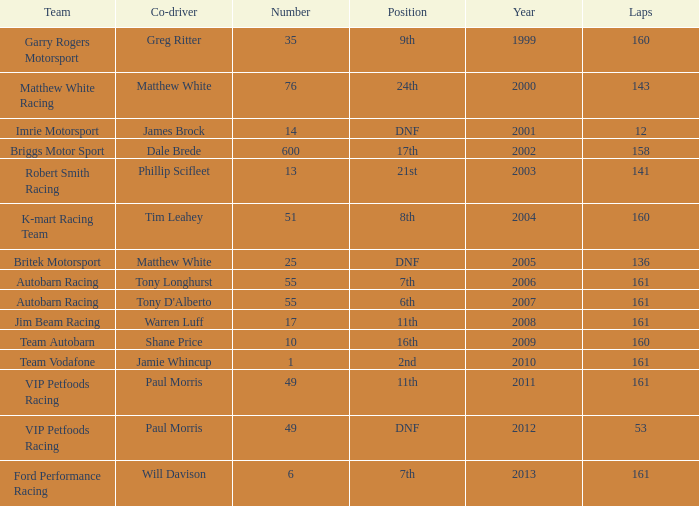Who was the co-driver for the team with more than 160 laps and the number 6 after 2010? Will Davison. 